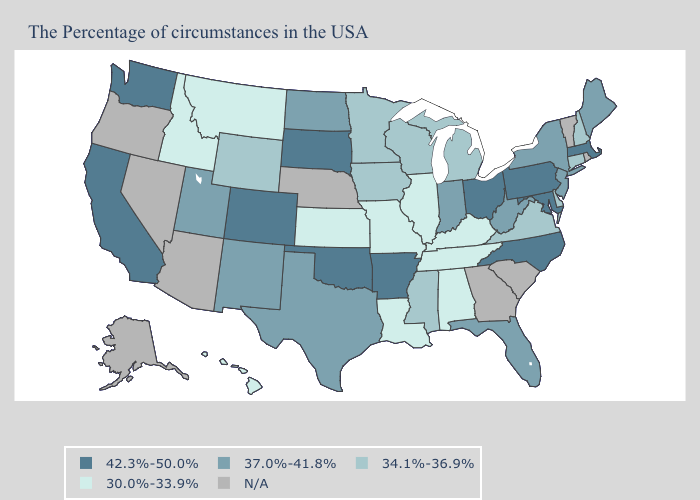Does Kentucky have the highest value in the South?
Keep it brief. No. Which states hav the highest value in the Northeast?
Concise answer only. Massachusetts, Pennsylvania. Name the states that have a value in the range 30.0%-33.9%?
Write a very short answer. Kentucky, Alabama, Tennessee, Illinois, Louisiana, Missouri, Kansas, Montana, Idaho, Hawaii. Name the states that have a value in the range 34.1%-36.9%?
Short answer required. New Hampshire, Connecticut, Delaware, Virginia, Michigan, Wisconsin, Mississippi, Minnesota, Iowa, Wyoming. Which states have the lowest value in the USA?
Concise answer only. Kentucky, Alabama, Tennessee, Illinois, Louisiana, Missouri, Kansas, Montana, Idaho, Hawaii. Among the states that border Mississippi , does Arkansas have the lowest value?
Be succinct. No. Name the states that have a value in the range 34.1%-36.9%?
Answer briefly. New Hampshire, Connecticut, Delaware, Virginia, Michigan, Wisconsin, Mississippi, Minnesota, Iowa, Wyoming. Does the first symbol in the legend represent the smallest category?
Concise answer only. No. What is the value of Hawaii?
Short answer required. 30.0%-33.9%. Name the states that have a value in the range 34.1%-36.9%?
Write a very short answer. New Hampshire, Connecticut, Delaware, Virginia, Michigan, Wisconsin, Mississippi, Minnesota, Iowa, Wyoming. What is the lowest value in the USA?
Concise answer only. 30.0%-33.9%. Does Louisiana have the lowest value in the USA?
Give a very brief answer. Yes. What is the value of California?
Write a very short answer. 42.3%-50.0%. 